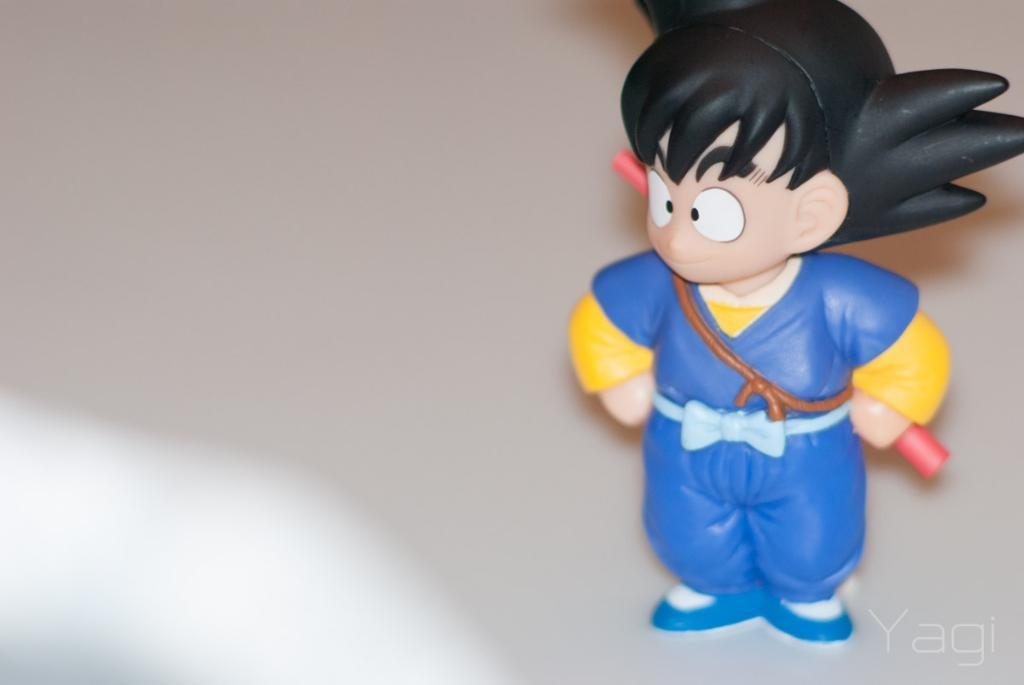What type of object is in the image? There is a toy of a man in the image. What is the toy man holding in his hands? The toy man is holding a blue dress. What is the toy man holding behind him? The toy man is holding a red-colored rod behind him. Can you see a river flowing in the background of the image? There is no river visible in the image; it features a toy man holding a blue dress and a red-colored rod. Is there a quiver of arrows attached to the toy man? There is no quiver of arrows present in the image. 